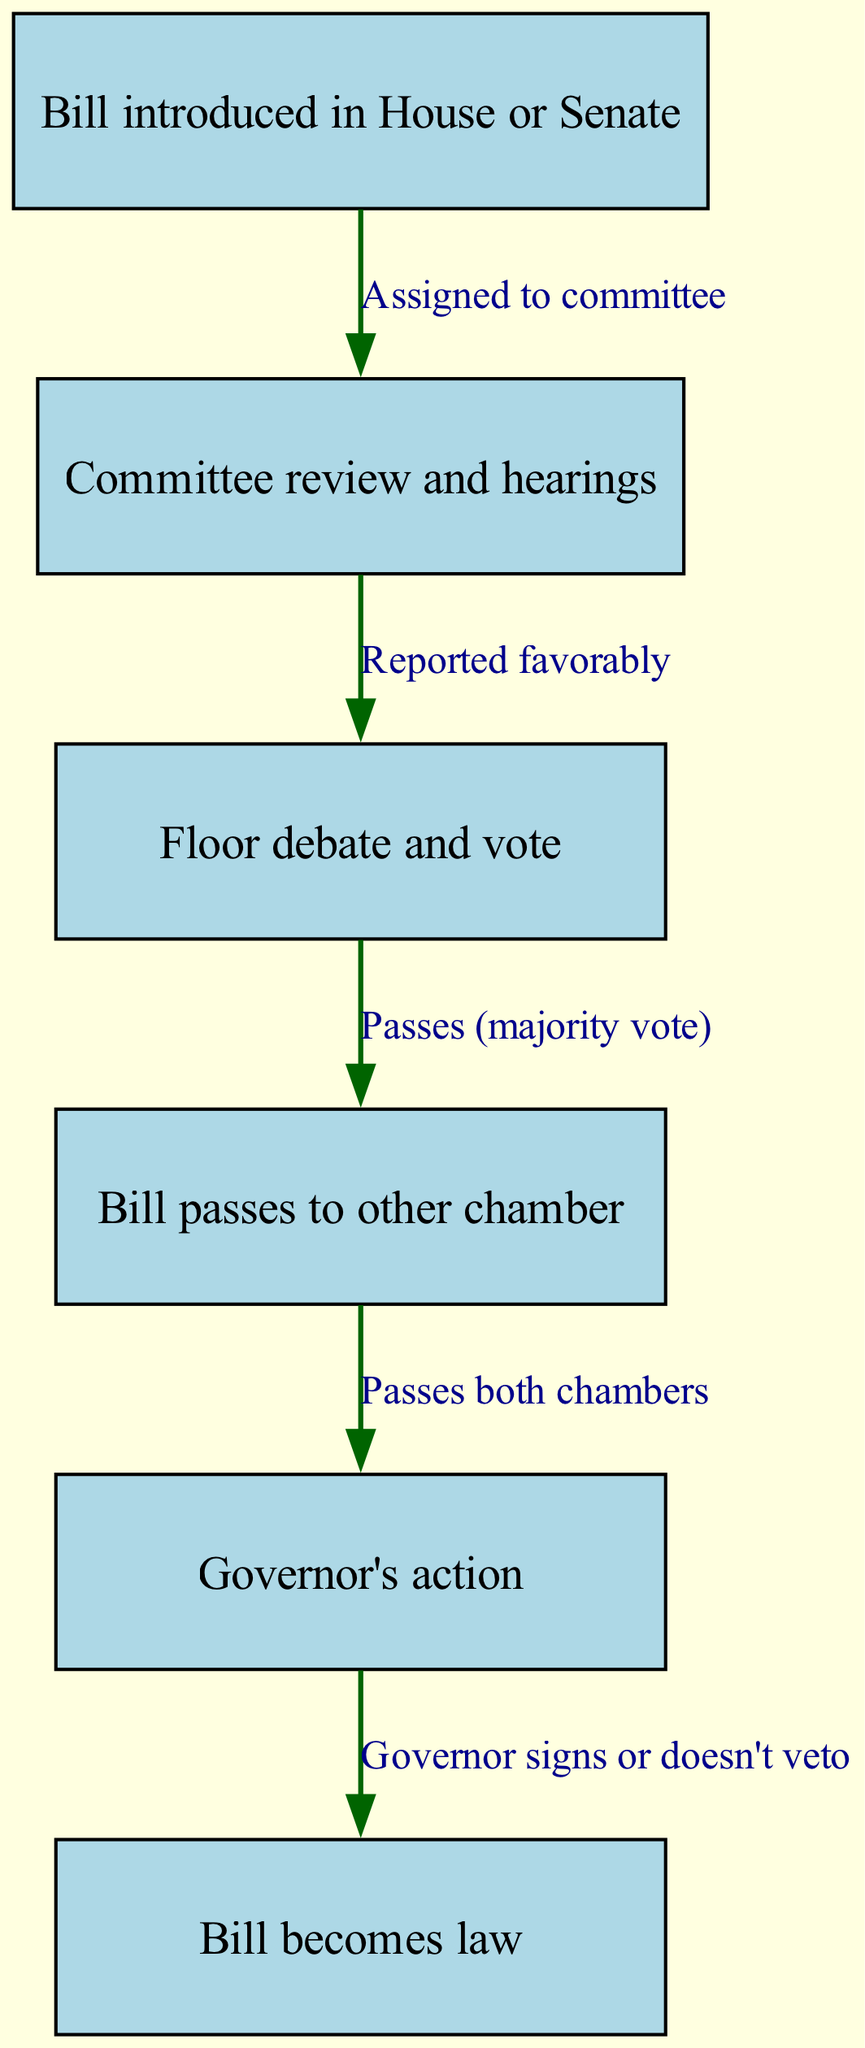What is the first step in the process? The diagram starts with the first node labeled "Bill introduced in House or Senate", indicating this is the initial step for the bill.
Answer: Bill introduced in House or Senate How many nodes are in the diagram? The diagram contains six nodes representing different steps in the legislative process, which can be counted directly from the nodes listed in the diagram.
Answer: 6 What action follows the committee review and hearings? According to the diagram, the next action after "Committee review and hearings" is "Floor debate and vote", as indicated by the directed edge connecting these two nodes.
Answer: Floor debate and vote What is required for a bill to pass from the floor debate? The diagram specifies that a bill must receive a "majority vote" to proceed from the "Floor debate and vote" node to the next stage, which is represented on the directed edge leading to the next node.
Answer: Passes (majority vote) What happens after a bill passes both chambers? Following the "Bill passes to other chamber" node, the diagram shows that the bill proceeds to "Governor's action", as indicated by the edge connecting these two nodes.
Answer: Governor's action What can the governor do after receiving a bill from the legislature? The diagram reveals that the governor can either sign the bill or choose not to veto it, which is explained in the directed edge from the "Governor's action" node to "Bill becomes law".
Answer: Governor signs or doesn't veto Which node is at the end of the legislative process? The final node in the diagram is labeled "Bill becomes law", indicating the conclusion of the process once all prior steps have been successfully completed.
Answer: Bill becomes law How many edges are in the diagram? By examining the connections between the nodes, there are five edges outlined in the diagram that represent the transitions between the various stages of how a bill becomes law.
Answer: 5 